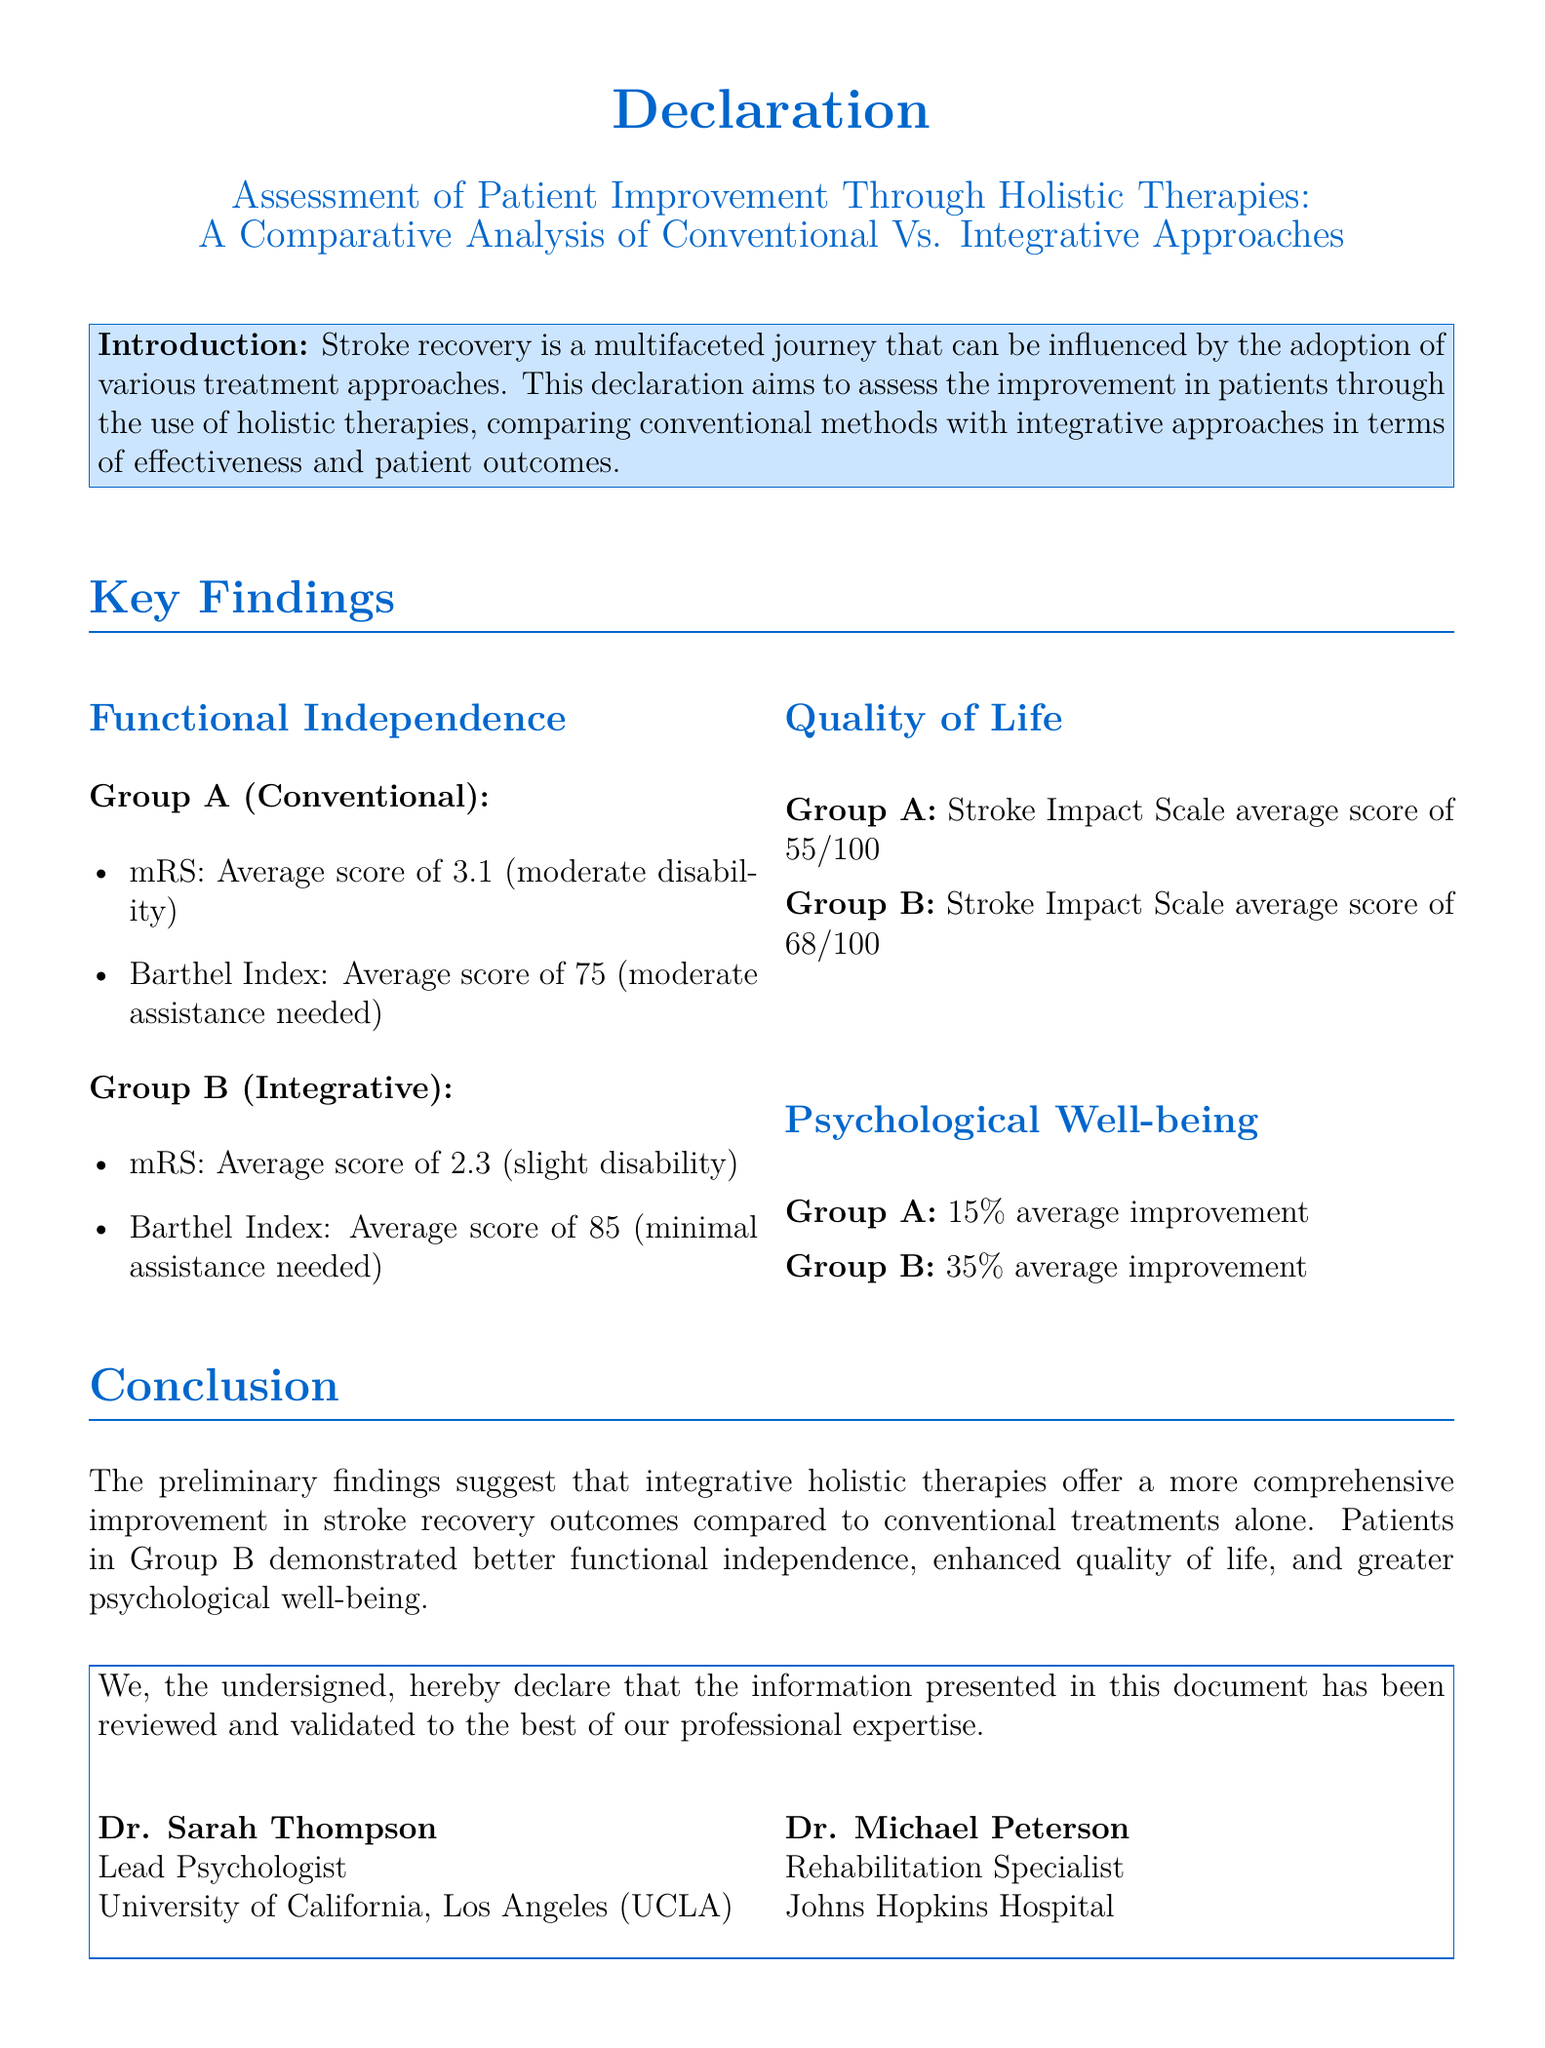What is the average mRS score for Group A? The average mRS score for Group A is explicitly stated in the document as 3.1.
Answer: 3.1 What is the Stroke Impact Scale average score for Group B? The document provides the average score for Group B on the Stroke Impact Scale, which is 68 out of 100.
Answer: 68/100 What is the average improvement in psychological well-being for Group B? The document specifies that Group B had a 35% average improvement in psychological well-being.
Answer: 35% Who is the lead psychologist listed in the declaration? The document mentions Dr. Sarah Thompson as the lead psychologist.
Answer: Dr. Sarah Thompson What conclusion can be drawn about the effectiveness of integrative therapies compared to conventional treatments? The conclusion summarized in the document states that integrative holistic therapies offer more comprehensive improvement compared to conventional methods.
Answer: More comprehensive improvement What is the average Barthel Index score for Group A? The average Barthel Index score for Group A is clearly mentioned as 75.
Answer: 75 What date was this document signed? The document states that it was signed on October 4, 2023.
Answer: October 4, 2023 What institution is Dr. Michael Peterson affiliated with? The document lists Johns Hopkins Hospital as the institution affiliated with Dr. Michael Peterson.
Answer: Johns Hopkins Hospital How much assistance did Group A need on average according to the Barthel Index? The document indicates that Group A needed moderate assistance based on their Barthel Index score.
Answer: Moderate assistance 